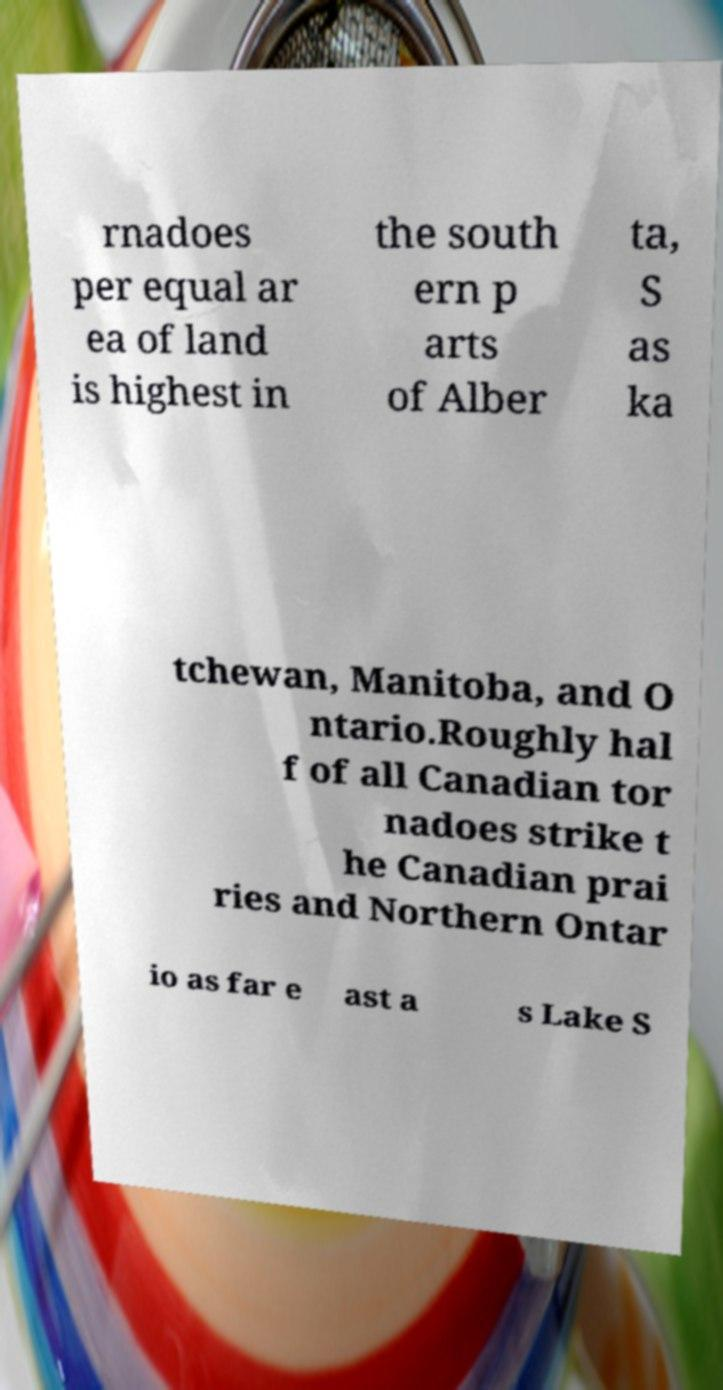Could you assist in decoding the text presented in this image and type it out clearly? rnadoes per equal ar ea of land is highest in the south ern p arts of Alber ta, S as ka tchewan, Manitoba, and O ntario.Roughly hal f of all Canadian tor nadoes strike t he Canadian prai ries and Northern Ontar io as far e ast a s Lake S 